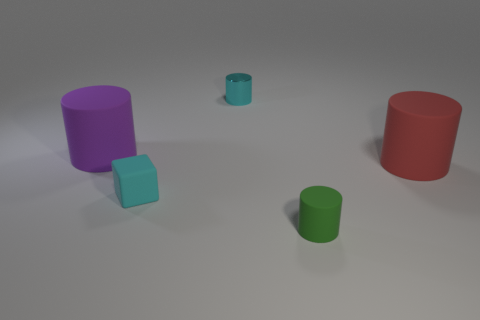Subtract all cyan cylinders. How many cylinders are left? 3 Subtract all cyan shiny cylinders. How many cylinders are left? 3 Add 2 small cylinders. How many objects exist? 7 Subtract 1 cylinders. How many cylinders are left? 3 Subtract all gray cylinders. Subtract all brown spheres. How many cylinders are left? 4 Subtract all blocks. How many objects are left? 4 Subtract all small matte things. Subtract all green matte cylinders. How many objects are left? 2 Add 4 cyan objects. How many cyan objects are left? 6 Add 2 small metallic things. How many small metallic things exist? 3 Subtract 0 brown cylinders. How many objects are left? 5 